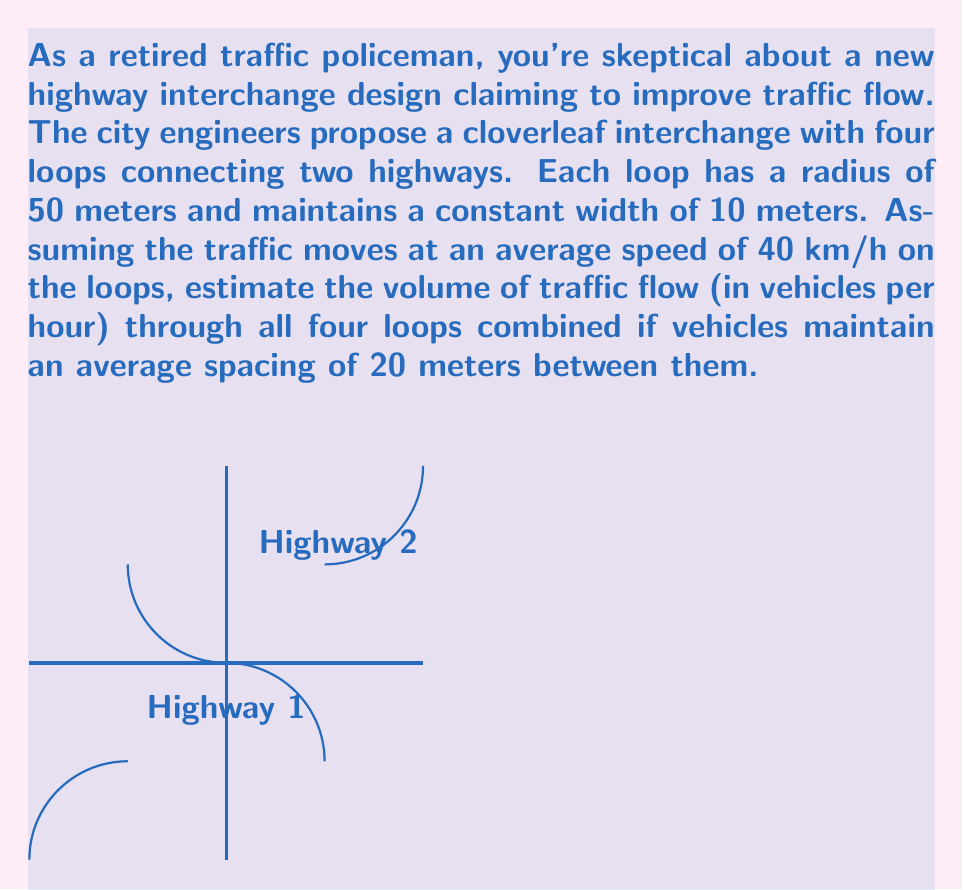Could you help me with this problem? Let's approach this step-by-step:

1) First, we need to calculate the length of one loop:
   Circumference of a loop = $2\pi r$ = $2\pi \cdot 50$ = $100\pi$ meters

2) The average speed is given as 40 km/h. Let's convert this to m/s:
   $40 \frac{km}{h} = 40 \cdot \frac{1000}{3600} \frac{m}{s} \approx 11.11 \frac{m}{s}$

3) Time taken for one vehicle to complete a loop:
   $T = \frac{distance}{speed} = \frac{100\pi}{11.11} \approx 28.27$ seconds

4) The spacing between vehicles is 20 meters. This means that a new vehicle can enter the loop every:
   $\frac{20}{11.11} \approx 1.80$ seconds

5) Number of vehicles that can enter one loop per hour:
   $N = \frac{3600}{1.80} = 2000$ vehicles/hour

6) Since there are four identical loops, the total flow through all loops:
   Total flow = $4 \cdot 2000 = 8000$ vehicles/hour

This estimate assumes continuous flow and doesn't account for potential slowdowns or gaps in traffic. In reality, the actual flow might be somewhat lower due to these factors.
Answer: 8000 vehicles/hour 